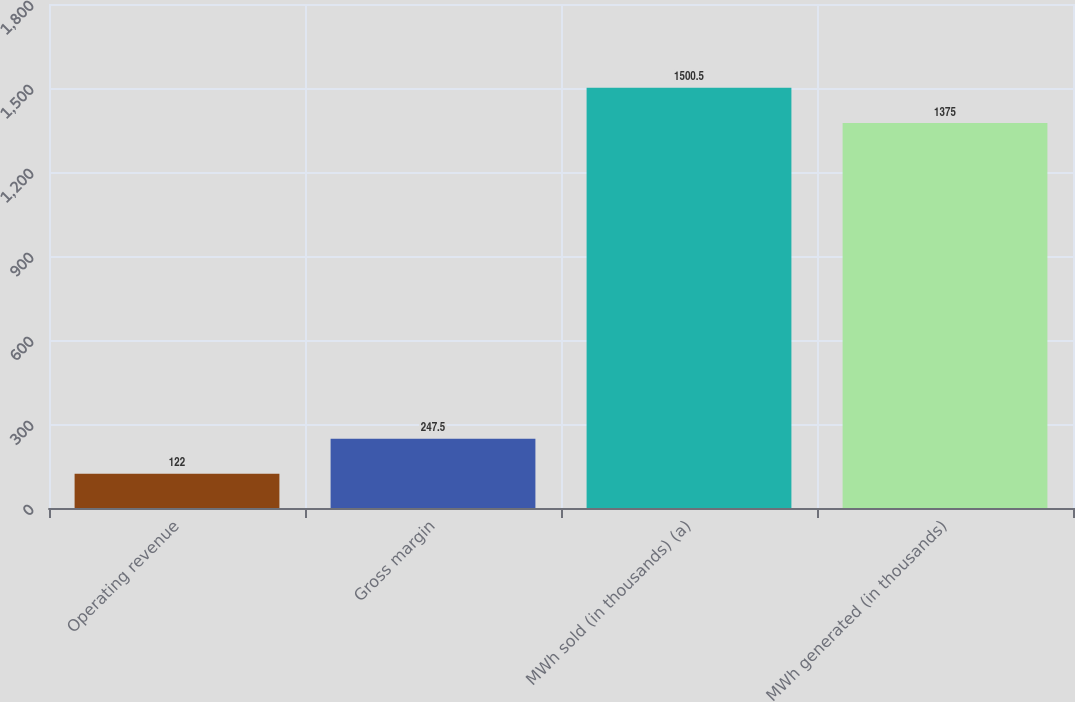<chart> <loc_0><loc_0><loc_500><loc_500><bar_chart><fcel>Operating revenue<fcel>Gross margin<fcel>MWh sold (in thousands) (a)<fcel>MWh generated (in thousands)<nl><fcel>122<fcel>247.5<fcel>1500.5<fcel>1375<nl></chart> 